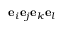Convert formula to latex. <formula><loc_0><loc_0><loc_500><loc_500>e _ { i } e _ { j } e _ { k } e _ { l }</formula> 